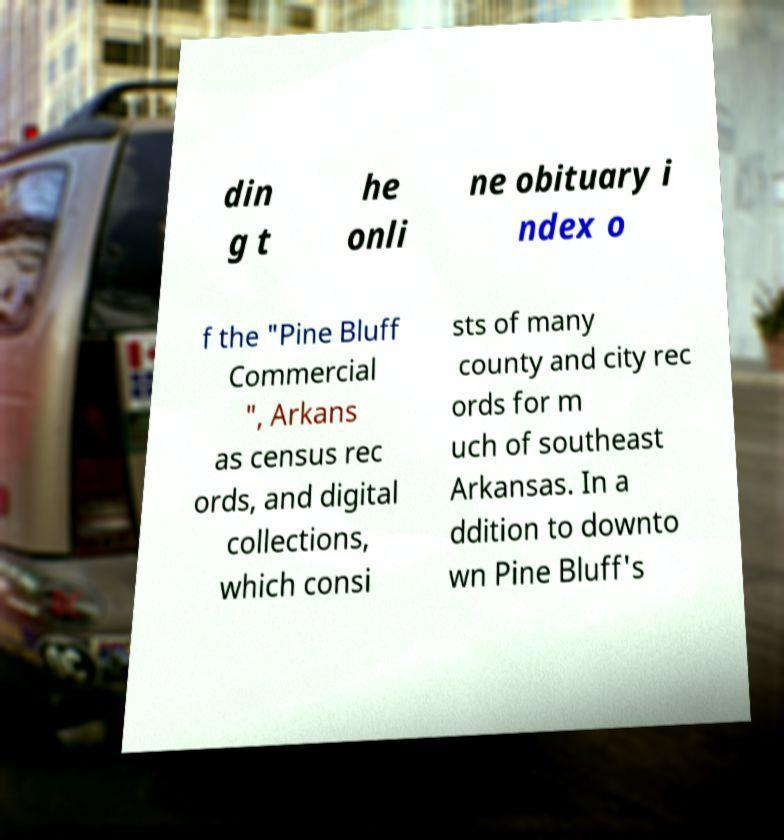What messages or text are displayed in this image? I need them in a readable, typed format. din g t he onli ne obituary i ndex o f the "Pine Bluff Commercial ", Arkans as census rec ords, and digital collections, which consi sts of many county and city rec ords for m uch of southeast Arkansas. In a ddition to downto wn Pine Bluff's 